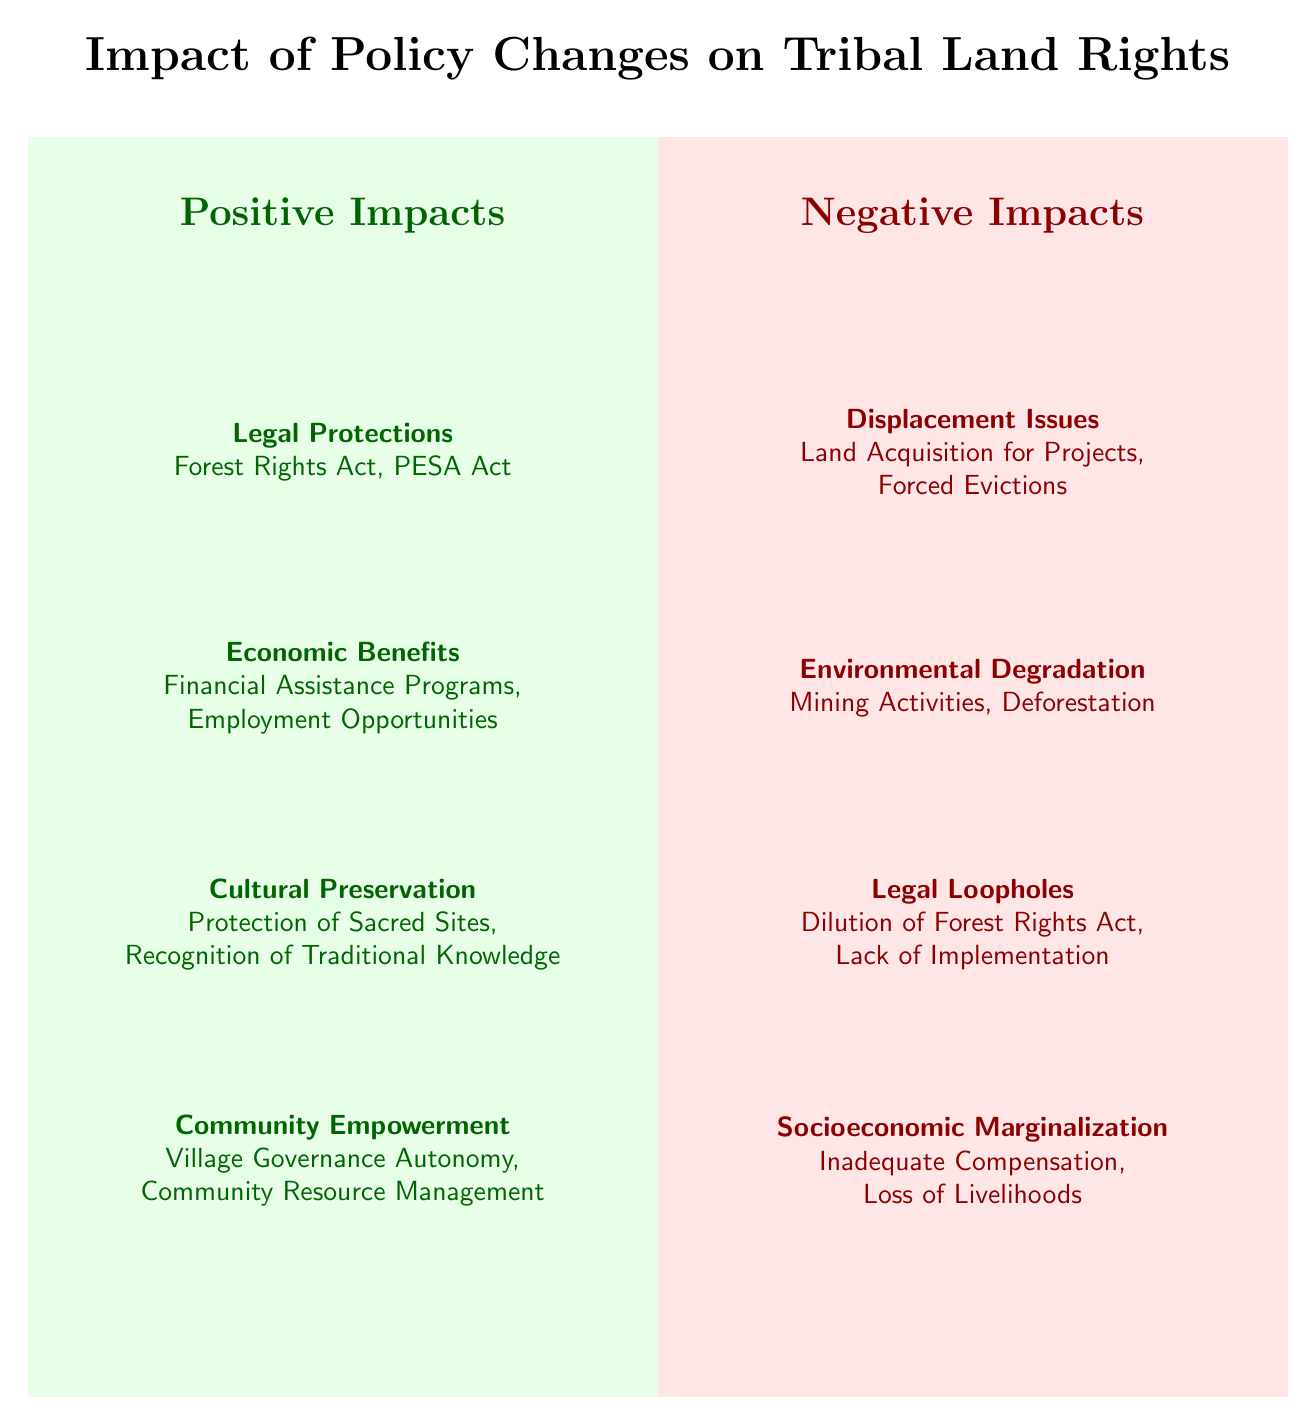What are the four categories of positive impacts? The diagram lists Legal Protections, Economic Benefits, Cultural Preservation, and Community Empowerment as the four categories of positive impacts.
Answer: Legal Protections, Economic Benefits, Cultural Preservation, Community Empowerment What are the negative impacts related to environmental issues? According to the diagram, the negative impacts related to environmental issues are Mining Activities and Deforestation.
Answer: Mining Activities, Deforestation How many total negative impact categories are listed? The diagram provides four categories of negative impacts: Displacement Issues, Environmental Degradation, Legal Loopholes, and Socioeconomic Marginalization. Therefore, the total is four.
Answer: 4 Which positive impact focuses on traditional knowledge? The diagram indicates that Cultural Preservation focuses on traditional knowledge, specifically through Recognition of Traditional Knowledge.
Answer: Cultural Preservation What is a negative impact caused by policy loopholes? The illustration shows that Legal Loopholes can lead to the Dilution of the Forest Rights Act and Lack of Implementation as negative impacts.
Answer: Dilution of Forest Rights Act, Lack of Implementation Which category of positive impacts mentions village governance? The diagram highlights that Community Empowerment mentions village governance through the concept of Village Governance Autonomy.
Answer: Community Empowerment What are the two issues associated with displacement in the negative impacts? The diagram specifies that the two issues associated with displacement in the negative impacts category are Land Acquisition for Projects and Forced Evictions.
Answer: Land Acquisition for Projects, Forced Evictions What does the positive impact 'Economic Benefits' include? The diagram indicates that Economic Benefits include Financial Assistance Programs and Employment Opportunities.
Answer: Financial Assistance Programs, Employment Opportunities In which quadrant is 'Socioeconomic Marginalization' located? The diagram places 'Socioeconomic Marginalization' in the bottom right quadrant, categorized under Negative Impacts.
Answer: Bottom right quadrant 